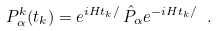<formula> <loc_0><loc_0><loc_500><loc_500>P ^ { k } _ { \alpha } ( t _ { k } ) = e ^ { i H t _ { k } / } \, \hat { P } _ { \alpha } e ^ { - i H t _ { k } / } \ .</formula> 